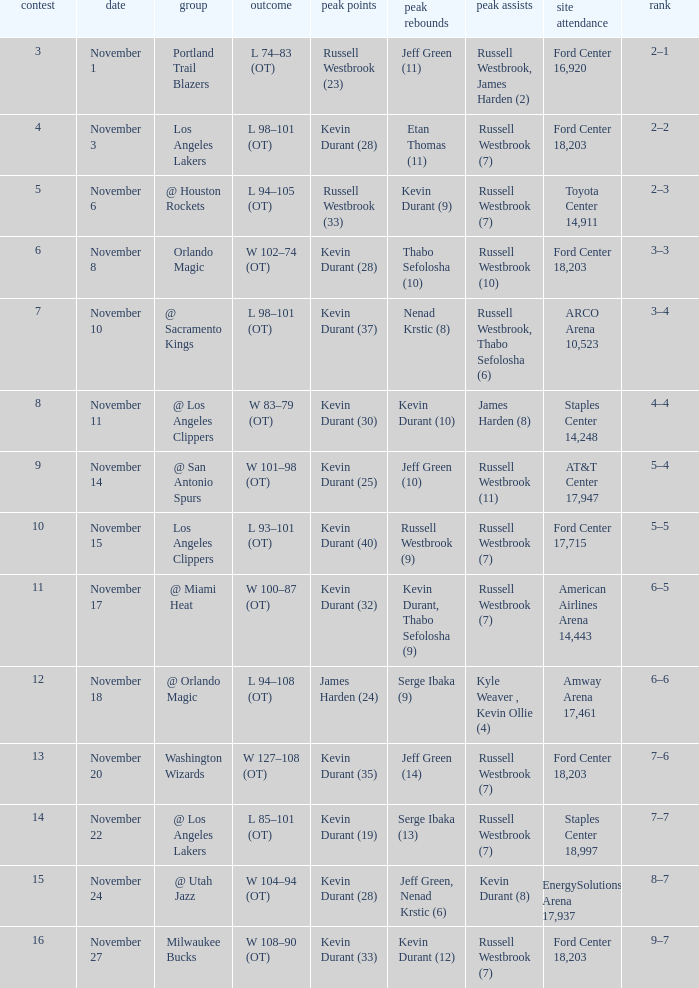When was the game number 3 played? November 1. 